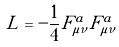<formula> <loc_0><loc_0><loc_500><loc_500>L = - \frac { 1 } { 4 } F _ { \mu \nu } ^ { a } F _ { \mu \nu } ^ { a }</formula> 